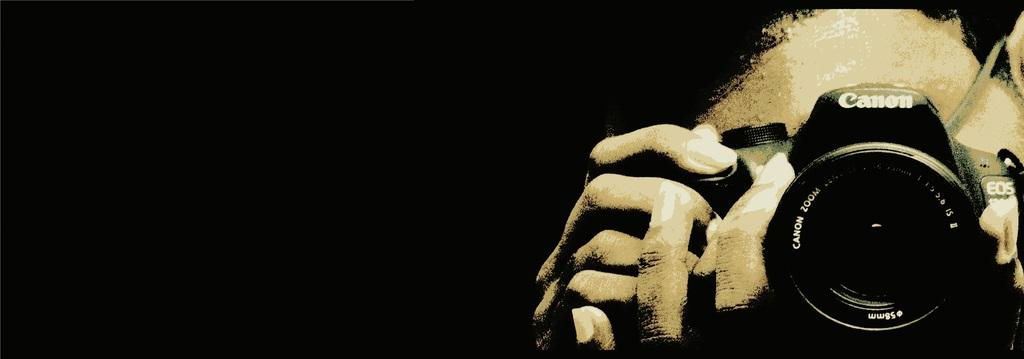What is the person in the image holding? The person is holding a Canon camera in the image. What can be seen in the background of the image? The background of the image is black. What type of plane is visible in the image? There is no plane visible in the image; it only features a person holding a Canon camera with a black background. 